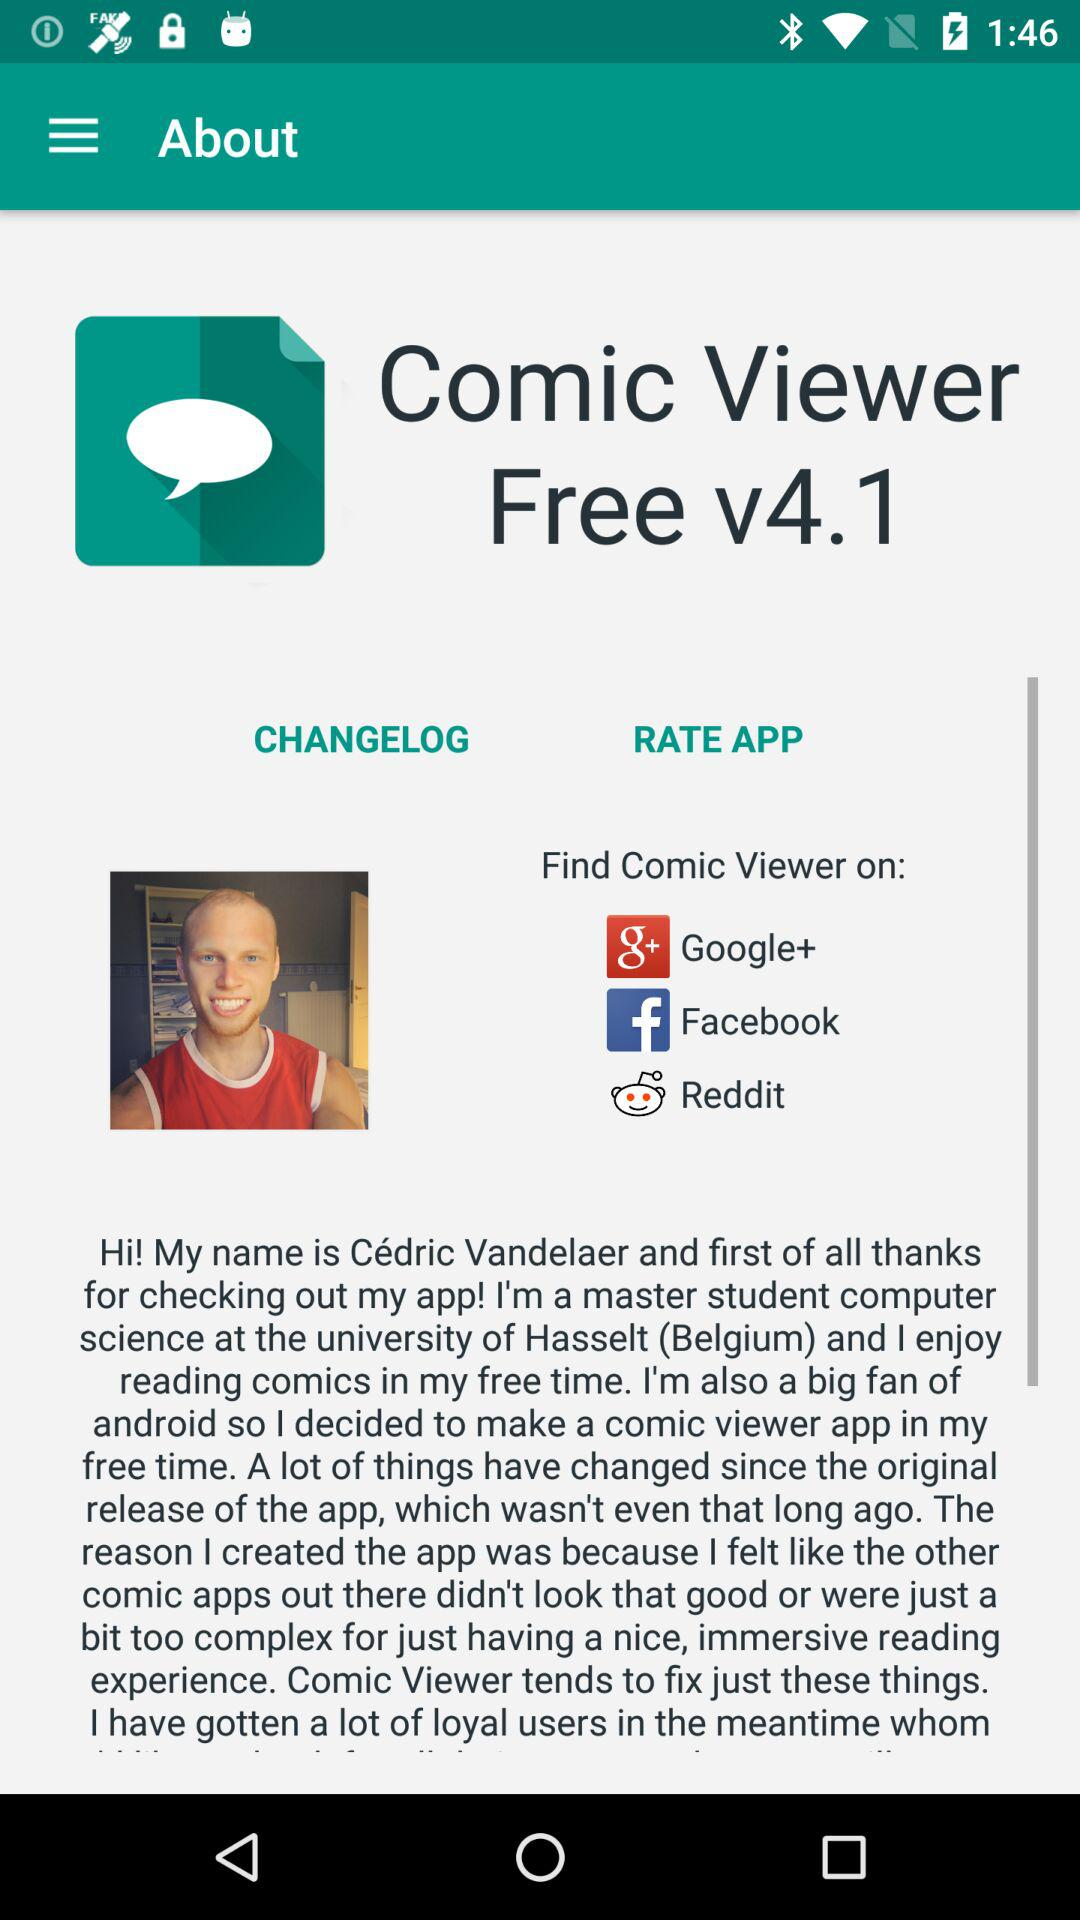What is the version of the application? The version of the application is 4.1. 